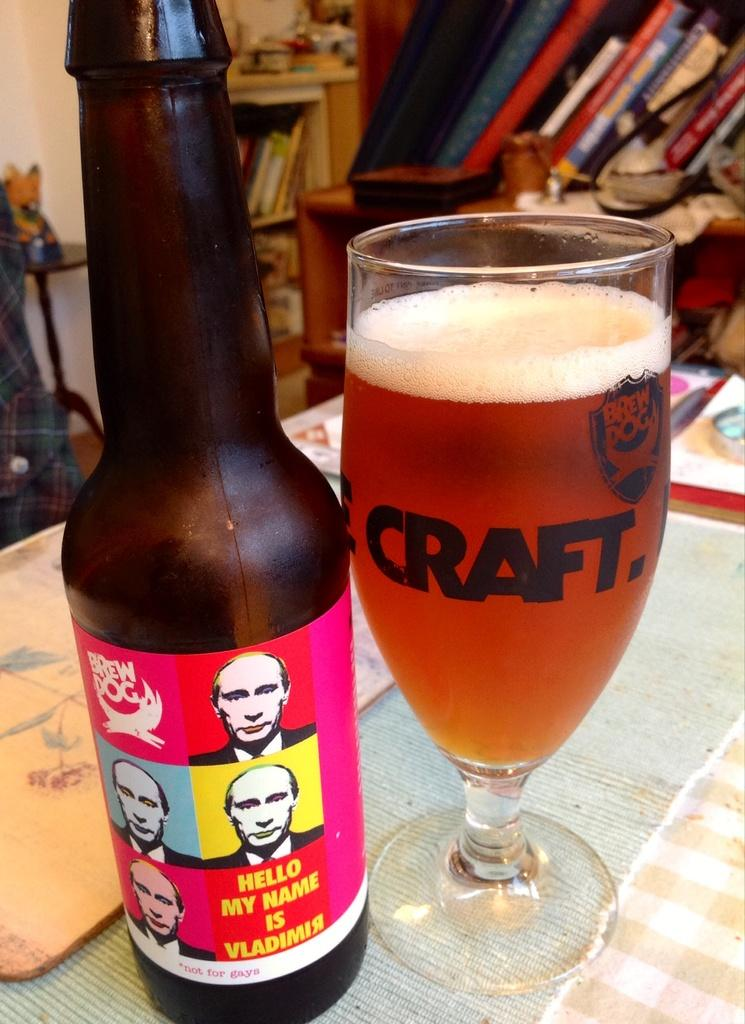<image>
Offer a succinct explanation of the picture presented. Hello, My Name is Vladimir is printed on the Brew Dog label of this craft beer. 